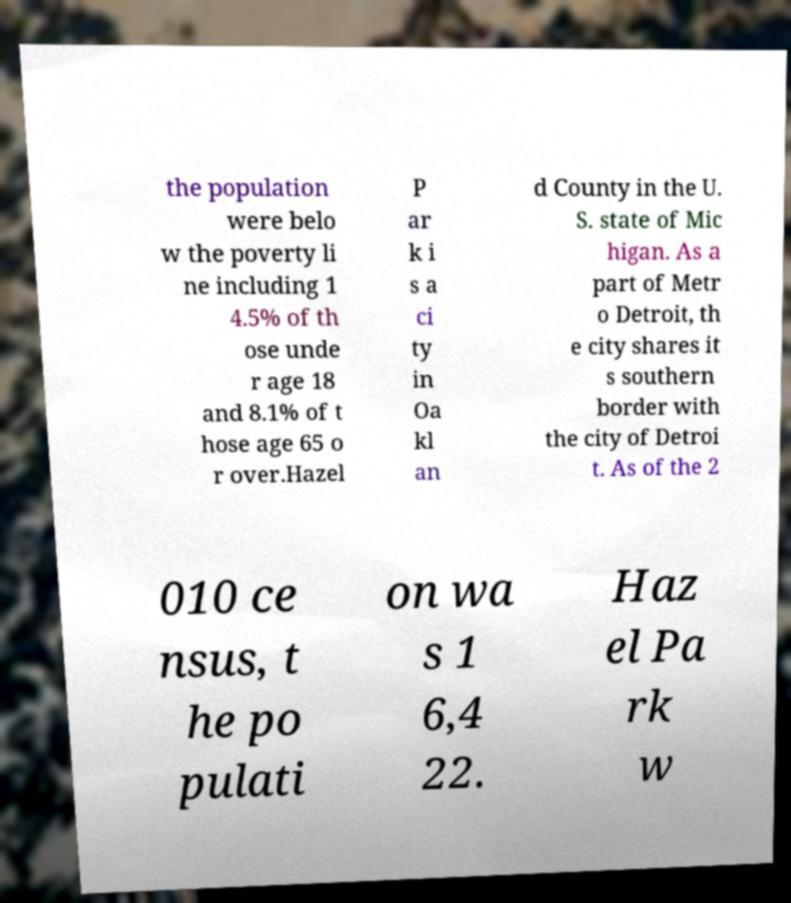Please read and relay the text visible in this image. What does it say? the population were belo w the poverty li ne including 1 4.5% of th ose unde r age 18 and 8.1% of t hose age 65 o r over.Hazel P ar k i s a ci ty in Oa kl an d County in the U. S. state of Mic higan. As a part of Metr o Detroit, th e city shares it s southern border with the city of Detroi t. As of the 2 010 ce nsus, t he po pulati on wa s 1 6,4 22. Haz el Pa rk w 